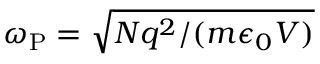<formula> <loc_0><loc_0><loc_500><loc_500>\omega _ { P } = \sqrt { N q ^ { 2 } / ( m \epsilon _ { 0 } V ) }</formula> 